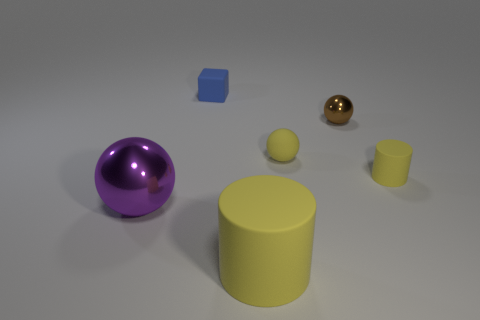Subtract all purple blocks. Subtract all brown cylinders. How many blocks are left? 1 Add 1 rubber objects. How many objects exist? 7 Subtract all cylinders. How many objects are left? 4 Subtract all blue matte cubes. Subtract all brown objects. How many objects are left? 4 Add 5 tiny rubber things. How many tiny rubber things are left? 8 Add 3 tiny matte cylinders. How many tiny matte cylinders exist? 4 Subtract 1 blue cubes. How many objects are left? 5 